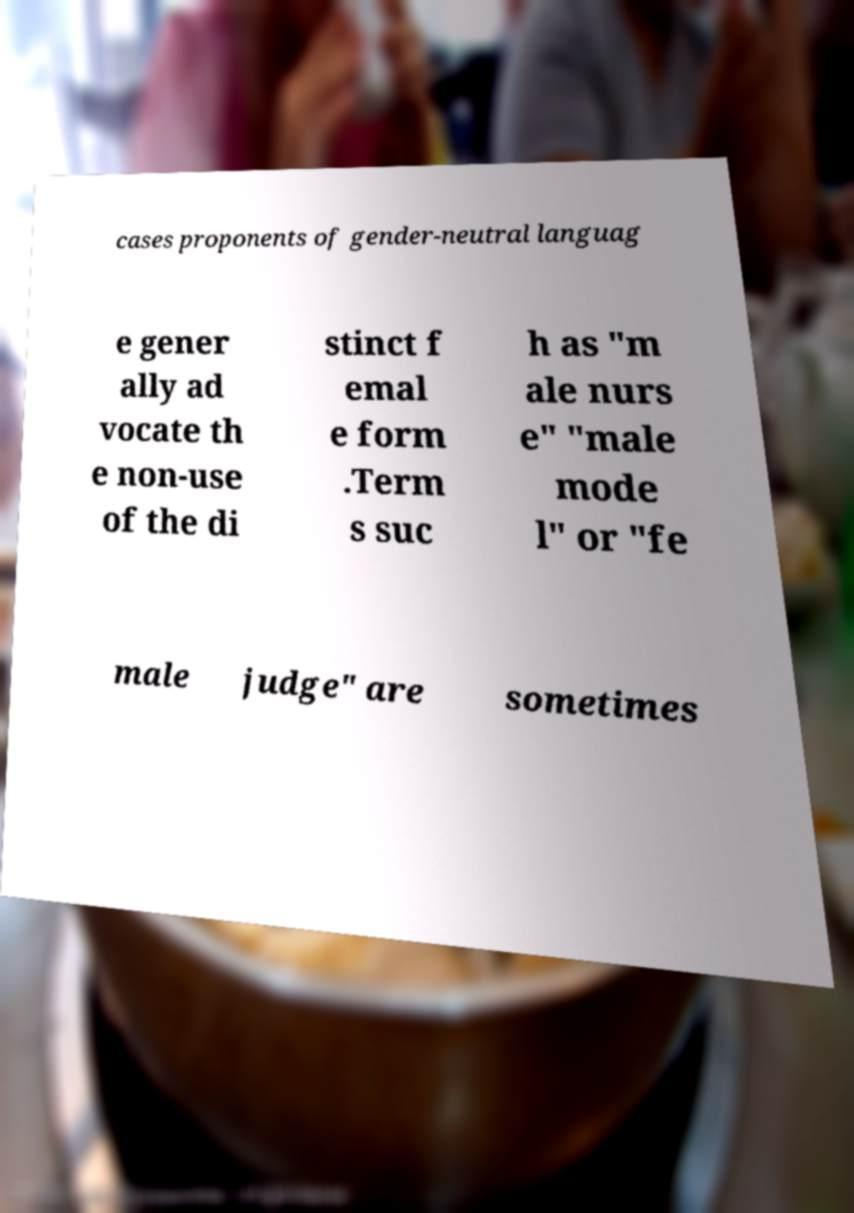Please read and relay the text visible in this image. What does it say? cases proponents of gender-neutral languag e gener ally ad vocate th e non-use of the di stinct f emal e form .Term s suc h as "m ale nurs e" "male mode l" or "fe male judge" are sometimes 